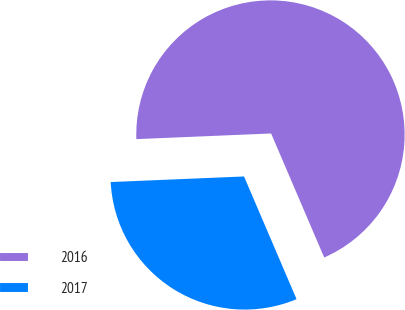Convert chart to OTSL. <chart><loc_0><loc_0><loc_500><loc_500><pie_chart><fcel>2016<fcel>2017<nl><fcel>69.23%<fcel>30.77%<nl></chart> 